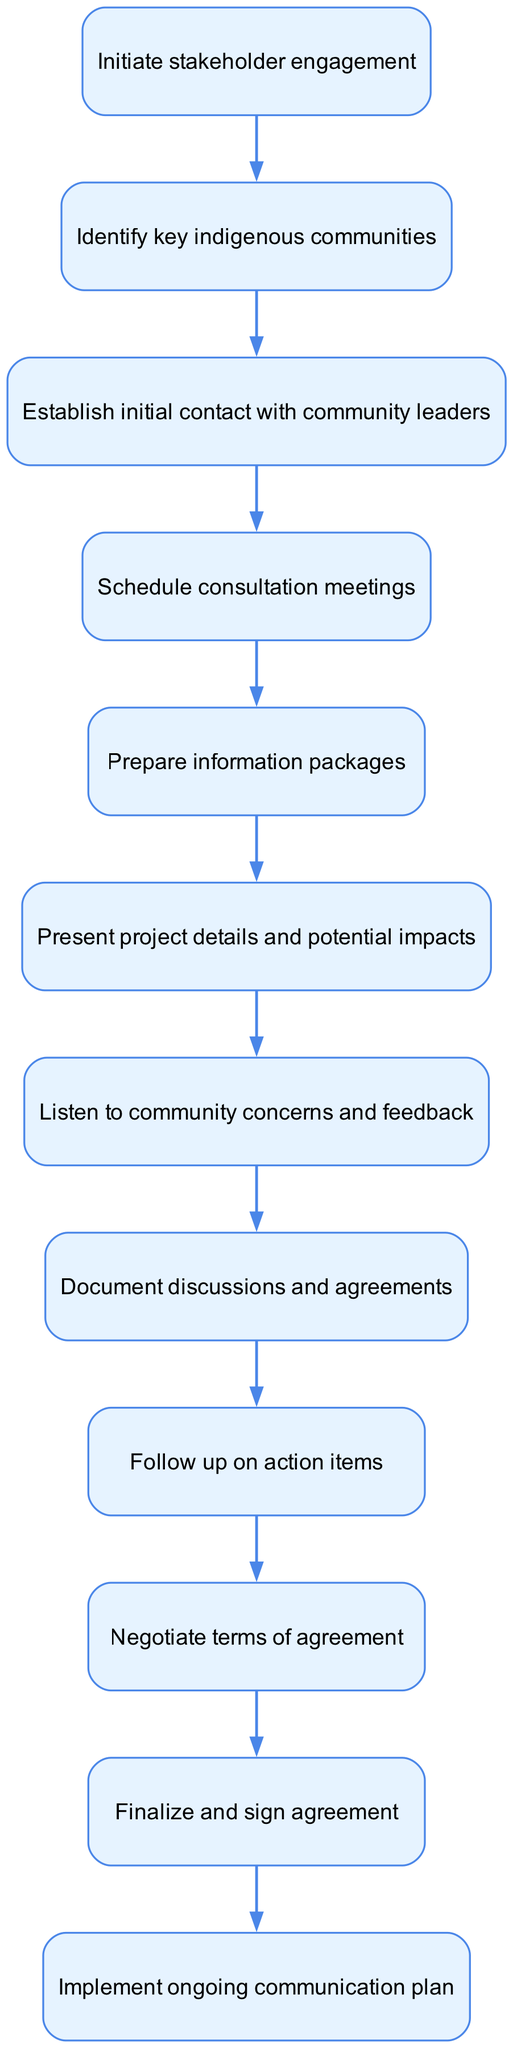What is the first step in the diagram? The diagram indicates that the first step is labeled 'Initiate stakeholder engagement.' This is the initial action that begins the flow of information sharing and consultation.
Answer: Initiate stakeholder engagement How many nodes are in the diagram? By counting all the unique actions represented in the diagram, there are a total of 12 nodes defined in the elements list.
Answer: 12 What is the last action before finalizing the agreement? The diagram shows that the last action before finalizing the agreement is 'Negotiate terms of agreement.' This step comes just before the final agreement is signed.
Answer: Negotiate terms of agreement What action follows listening to community concerns? According to the flow chart, after 'Listen to community concerns and feedback,' the next action is 'Document discussions and agreements.' This indicates the flow from listening to recording the feedback.
Answer: Document discussions and agreements What step involves preparing information for stakeholders? The step that involves preparation of information for stakeholders is clearly labeled as 'Prepare information packages.' This indicates that relevant and necessary information is compiled before presenting it.
Answer: Prepare information packages What is the relationship between 'Establish initial contact with community leaders' and 'Schedule consultation meetings'? In the diagram, the relationship shows that after 'Establish initial contact with community leaders,' the next logical step is to 'Schedule consultation meetings.' This indicates a direct progression from contacting leaders to arranging meetings with them.
Answer: Schedule consultation meetings Which action occurs directly after documenting discussions? The action that occurs directly after documenting discussions is 'Follow up on action items.' This indicates the continuation of the process to ensure that the recorded agreements are addressed.
Answer: Follow up on action items How many connections are there between the nodes? By looking at the connections represented in the diagram, we can see that there are a total of 11 connections, linking all the actions in the flow.
Answer: 11 What is the purpose of 'Present project details and potential impacts'? The purpose of this step is to inform stakeholders about the specifics of the project and highlight its possible effects on the community, serving as a crucial part of the consultation process.
Answer: Present project details and potential impacts 